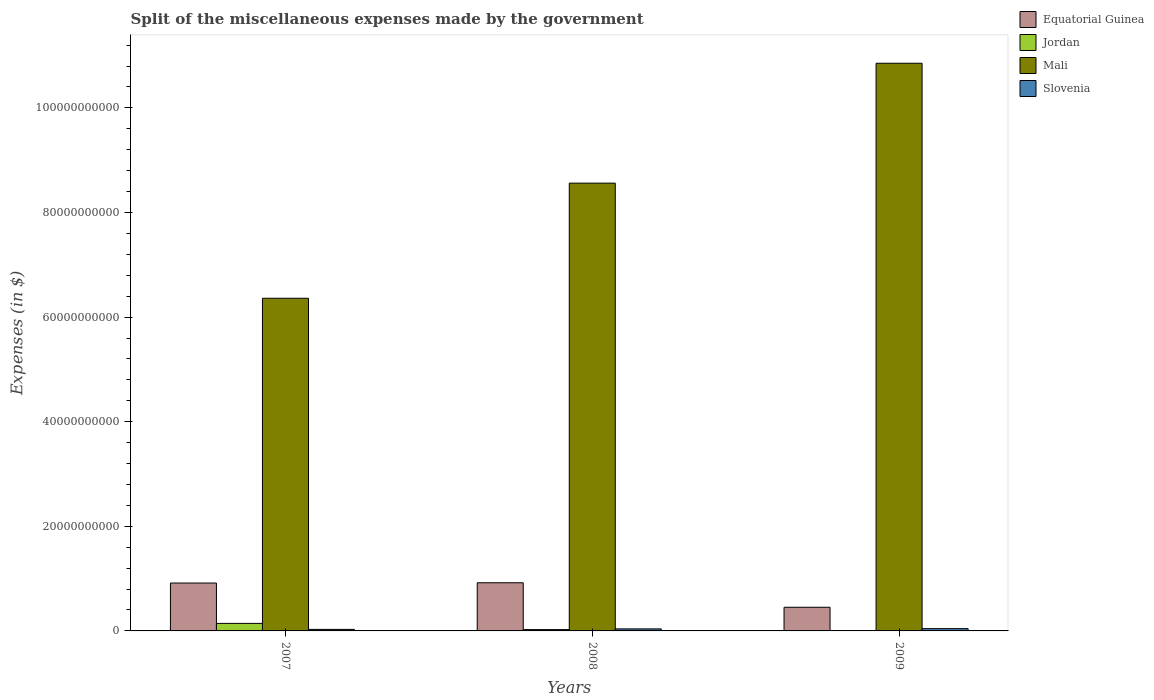How many groups of bars are there?
Offer a very short reply. 3. Are the number of bars per tick equal to the number of legend labels?
Provide a succinct answer. Yes. Are the number of bars on each tick of the X-axis equal?
Keep it short and to the point. Yes. How many bars are there on the 3rd tick from the right?
Your answer should be very brief. 4. In how many cases, is the number of bars for a given year not equal to the number of legend labels?
Make the answer very short. 0. What is the miscellaneous expenses made by the government in Jordan in 2007?
Your response must be concise. 1.44e+09. Across all years, what is the maximum miscellaneous expenses made by the government in Equatorial Guinea?
Offer a very short reply. 9.21e+09. Across all years, what is the minimum miscellaneous expenses made by the government in Equatorial Guinea?
Provide a short and direct response. 4.52e+09. In which year was the miscellaneous expenses made by the government in Slovenia maximum?
Give a very brief answer. 2009. What is the total miscellaneous expenses made by the government in Equatorial Guinea in the graph?
Keep it short and to the point. 2.29e+1. What is the difference between the miscellaneous expenses made by the government in Mali in 2007 and that in 2008?
Offer a very short reply. -2.20e+1. What is the difference between the miscellaneous expenses made by the government in Slovenia in 2007 and the miscellaneous expenses made by the government in Jordan in 2009?
Give a very brief answer. 2.18e+08. What is the average miscellaneous expenses made by the government in Jordan per year?
Your answer should be very brief. 5.90e+08. In the year 2009, what is the difference between the miscellaneous expenses made by the government in Jordan and miscellaneous expenses made by the government in Equatorial Guinea?
Your answer should be very brief. -4.44e+09. In how many years, is the miscellaneous expenses made by the government in Mali greater than 80000000000 $?
Keep it short and to the point. 2. What is the ratio of the miscellaneous expenses made by the government in Slovenia in 2008 to that in 2009?
Provide a short and direct response. 0.9. Is the difference between the miscellaneous expenses made by the government in Jordan in 2008 and 2009 greater than the difference between the miscellaneous expenses made by the government in Equatorial Guinea in 2008 and 2009?
Offer a terse response. No. What is the difference between the highest and the second highest miscellaneous expenses made by the government in Jordan?
Provide a succinct answer. 1.18e+09. What is the difference between the highest and the lowest miscellaneous expenses made by the government in Slovenia?
Offer a terse response. 1.38e+08. Is the sum of the miscellaneous expenses made by the government in Mali in 2008 and 2009 greater than the maximum miscellaneous expenses made by the government in Slovenia across all years?
Provide a succinct answer. Yes. What does the 4th bar from the left in 2009 represents?
Offer a terse response. Slovenia. What does the 2nd bar from the right in 2008 represents?
Provide a short and direct response. Mali. Is it the case that in every year, the sum of the miscellaneous expenses made by the government in Slovenia and miscellaneous expenses made by the government in Mali is greater than the miscellaneous expenses made by the government in Jordan?
Your answer should be compact. Yes. How many years are there in the graph?
Your response must be concise. 3. What is the difference between two consecutive major ticks on the Y-axis?
Keep it short and to the point. 2.00e+1. Does the graph contain grids?
Ensure brevity in your answer.  No. Where does the legend appear in the graph?
Your answer should be compact. Top right. How are the legend labels stacked?
Ensure brevity in your answer.  Vertical. What is the title of the graph?
Offer a terse response. Split of the miscellaneous expenses made by the government. Does "Sri Lanka" appear as one of the legend labels in the graph?
Offer a terse response. No. What is the label or title of the X-axis?
Offer a very short reply. Years. What is the label or title of the Y-axis?
Provide a short and direct response. Expenses (in $). What is the Expenses (in $) of Equatorial Guinea in 2007?
Make the answer very short. 9.16e+09. What is the Expenses (in $) in Jordan in 2007?
Offer a very short reply. 1.44e+09. What is the Expenses (in $) of Mali in 2007?
Provide a short and direct response. 6.36e+1. What is the Expenses (in $) of Slovenia in 2007?
Provide a short and direct response. 2.95e+08. What is the Expenses (in $) of Equatorial Guinea in 2008?
Give a very brief answer. 9.21e+09. What is the Expenses (in $) in Jordan in 2008?
Provide a succinct answer. 2.55e+08. What is the Expenses (in $) in Mali in 2008?
Give a very brief answer. 8.56e+1. What is the Expenses (in $) of Slovenia in 2008?
Keep it short and to the point. 3.89e+08. What is the Expenses (in $) in Equatorial Guinea in 2009?
Your response must be concise. 4.52e+09. What is the Expenses (in $) in Jordan in 2009?
Your response must be concise. 7.76e+07. What is the Expenses (in $) in Mali in 2009?
Offer a terse response. 1.09e+11. What is the Expenses (in $) of Slovenia in 2009?
Ensure brevity in your answer.  4.33e+08. Across all years, what is the maximum Expenses (in $) in Equatorial Guinea?
Give a very brief answer. 9.21e+09. Across all years, what is the maximum Expenses (in $) in Jordan?
Offer a very short reply. 1.44e+09. Across all years, what is the maximum Expenses (in $) of Mali?
Ensure brevity in your answer.  1.09e+11. Across all years, what is the maximum Expenses (in $) of Slovenia?
Give a very brief answer. 4.33e+08. Across all years, what is the minimum Expenses (in $) of Equatorial Guinea?
Your answer should be very brief. 4.52e+09. Across all years, what is the minimum Expenses (in $) in Jordan?
Your answer should be very brief. 7.76e+07. Across all years, what is the minimum Expenses (in $) in Mali?
Offer a terse response. 6.36e+1. Across all years, what is the minimum Expenses (in $) of Slovenia?
Give a very brief answer. 2.95e+08. What is the total Expenses (in $) in Equatorial Guinea in the graph?
Give a very brief answer. 2.29e+1. What is the total Expenses (in $) of Jordan in the graph?
Provide a succinct answer. 1.77e+09. What is the total Expenses (in $) in Mali in the graph?
Your response must be concise. 2.58e+11. What is the total Expenses (in $) in Slovenia in the graph?
Your answer should be compact. 1.12e+09. What is the difference between the Expenses (in $) in Equatorial Guinea in 2007 and that in 2008?
Your answer should be very brief. -5.30e+07. What is the difference between the Expenses (in $) in Jordan in 2007 and that in 2008?
Provide a short and direct response. 1.18e+09. What is the difference between the Expenses (in $) in Mali in 2007 and that in 2008?
Keep it short and to the point. -2.20e+1. What is the difference between the Expenses (in $) of Slovenia in 2007 and that in 2008?
Offer a terse response. -9.37e+07. What is the difference between the Expenses (in $) in Equatorial Guinea in 2007 and that in 2009?
Provide a succinct answer. 4.63e+09. What is the difference between the Expenses (in $) of Jordan in 2007 and that in 2009?
Your answer should be very brief. 1.36e+09. What is the difference between the Expenses (in $) of Mali in 2007 and that in 2009?
Ensure brevity in your answer.  -4.49e+1. What is the difference between the Expenses (in $) in Slovenia in 2007 and that in 2009?
Your answer should be very brief. -1.38e+08. What is the difference between the Expenses (in $) of Equatorial Guinea in 2008 and that in 2009?
Offer a terse response. 4.69e+09. What is the difference between the Expenses (in $) of Jordan in 2008 and that in 2009?
Provide a succinct answer. 1.78e+08. What is the difference between the Expenses (in $) in Mali in 2008 and that in 2009?
Keep it short and to the point. -2.29e+1. What is the difference between the Expenses (in $) of Slovenia in 2008 and that in 2009?
Offer a very short reply. -4.41e+07. What is the difference between the Expenses (in $) of Equatorial Guinea in 2007 and the Expenses (in $) of Jordan in 2008?
Your response must be concise. 8.90e+09. What is the difference between the Expenses (in $) in Equatorial Guinea in 2007 and the Expenses (in $) in Mali in 2008?
Give a very brief answer. -7.65e+1. What is the difference between the Expenses (in $) of Equatorial Guinea in 2007 and the Expenses (in $) of Slovenia in 2008?
Offer a terse response. 8.77e+09. What is the difference between the Expenses (in $) of Jordan in 2007 and the Expenses (in $) of Mali in 2008?
Your answer should be compact. -8.42e+1. What is the difference between the Expenses (in $) in Jordan in 2007 and the Expenses (in $) in Slovenia in 2008?
Offer a very short reply. 1.05e+09. What is the difference between the Expenses (in $) of Mali in 2007 and the Expenses (in $) of Slovenia in 2008?
Ensure brevity in your answer.  6.32e+1. What is the difference between the Expenses (in $) of Equatorial Guinea in 2007 and the Expenses (in $) of Jordan in 2009?
Make the answer very short. 9.08e+09. What is the difference between the Expenses (in $) in Equatorial Guinea in 2007 and the Expenses (in $) in Mali in 2009?
Keep it short and to the point. -9.94e+1. What is the difference between the Expenses (in $) in Equatorial Guinea in 2007 and the Expenses (in $) in Slovenia in 2009?
Ensure brevity in your answer.  8.72e+09. What is the difference between the Expenses (in $) of Jordan in 2007 and the Expenses (in $) of Mali in 2009?
Offer a very short reply. -1.07e+11. What is the difference between the Expenses (in $) of Jordan in 2007 and the Expenses (in $) of Slovenia in 2009?
Keep it short and to the point. 1.01e+09. What is the difference between the Expenses (in $) in Mali in 2007 and the Expenses (in $) in Slovenia in 2009?
Keep it short and to the point. 6.32e+1. What is the difference between the Expenses (in $) in Equatorial Guinea in 2008 and the Expenses (in $) in Jordan in 2009?
Give a very brief answer. 9.13e+09. What is the difference between the Expenses (in $) in Equatorial Guinea in 2008 and the Expenses (in $) in Mali in 2009?
Ensure brevity in your answer.  -9.93e+1. What is the difference between the Expenses (in $) in Equatorial Guinea in 2008 and the Expenses (in $) in Slovenia in 2009?
Ensure brevity in your answer.  8.78e+09. What is the difference between the Expenses (in $) of Jordan in 2008 and the Expenses (in $) of Mali in 2009?
Ensure brevity in your answer.  -1.08e+11. What is the difference between the Expenses (in $) of Jordan in 2008 and the Expenses (in $) of Slovenia in 2009?
Keep it short and to the point. -1.78e+08. What is the difference between the Expenses (in $) of Mali in 2008 and the Expenses (in $) of Slovenia in 2009?
Give a very brief answer. 8.52e+1. What is the average Expenses (in $) of Equatorial Guinea per year?
Make the answer very short. 7.63e+09. What is the average Expenses (in $) of Jordan per year?
Your response must be concise. 5.90e+08. What is the average Expenses (in $) in Mali per year?
Provide a short and direct response. 8.59e+1. What is the average Expenses (in $) in Slovenia per year?
Offer a very short reply. 3.73e+08. In the year 2007, what is the difference between the Expenses (in $) in Equatorial Guinea and Expenses (in $) in Jordan?
Ensure brevity in your answer.  7.72e+09. In the year 2007, what is the difference between the Expenses (in $) of Equatorial Guinea and Expenses (in $) of Mali?
Your answer should be compact. -5.44e+1. In the year 2007, what is the difference between the Expenses (in $) of Equatorial Guinea and Expenses (in $) of Slovenia?
Your response must be concise. 8.86e+09. In the year 2007, what is the difference between the Expenses (in $) of Jordan and Expenses (in $) of Mali?
Offer a very short reply. -6.22e+1. In the year 2007, what is the difference between the Expenses (in $) of Jordan and Expenses (in $) of Slovenia?
Keep it short and to the point. 1.14e+09. In the year 2007, what is the difference between the Expenses (in $) in Mali and Expenses (in $) in Slovenia?
Make the answer very short. 6.33e+1. In the year 2008, what is the difference between the Expenses (in $) of Equatorial Guinea and Expenses (in $) of Jordan?
Offer a very short reply. 8.95e+09. In the year 2008, what is the difference between the Expenses (in $) in Equatorial Guinea and Expenses (in $) in Mali?
Your response must be concise. -7.64e+1. In the year 2008, what is the difference between the Expenses (in $) in Equatorial Guinea and Expenses (in $) in Slovenia?
Make the answer very short. 8.82e+09. In the year 2008, what is the difference between the Expenses (in $) of Jordan and Expenses (in $) of Mali?
Provide a short and direct response. -8.54e+1. In the year 2008, what is the difference between the Expenses (in $) of Jordan and Expenses (in $) of Slovenia?
Give a very brief answer. -1.34e+08. In the year 2008, what is the difference between the Expenses (in $) in Mali and Expenses (in $) in Slovenia?
Your answer should be very brief. 8.52e+1. In the year 2009, what is the difference between the Expenses (in $) of Equatorial Guinea and Expenses (in $) of Jordan?
Provide a short and direct response. 4.44e+09. In the year 2009, what is the difference between the Expenses (in $) in Equatorial Guinea and Expenses (in $) in Mali?
Your response must be concise. -1.04e+11. In the year 2009, what is the difference between the Expenses (in $) in Equatorial Guinea and Expenses (in $) in Slovenia?
Ensure brevity in your answer.  4.09e+09. In the year 2009, what is the difference between the Expenses (in $) in Jordan and Expenses (in $) in Mali?
Make the answer very short. -1.08e+11. In the year 2009, what is the difference between the Expenses (in $) of Jordan and Expenses (in $) of Slovenia?
Your answer should be compact. -3.56e+08. In the year 2009, what is the difference between the Expenses (in $) of Mali and Expenses (in $) of Slovenia?
Make the answer very short. 1.08e+11. What is the ratio of the Expenses (in $) of Equatorial Guinea in 2007 to that in 2008?
Your answer should be very brief. 0.99. What is the ratio of the Expenses (in $) of Jordan in 2007 to that in 2008?
Ensure brevity in your answer.  5.63. What is the ratio of the Expenses (in $) in Mali in 2007 to that in 2008?
Give a very brief answer. 0.74. What is the ratio of the Expenses (in $) in Slovenia in 2007 to that in 2008?
Keep it short and to the point. 0.76. What is the ratio of the Expenses (in $) of Equatorial Guinea in 2007 to that in 2009?
Your answer should be very brief. 2.02. What is the ratio of the Expenses (in $) in Jordan in 2007 to that in 2009?
Provide a succinct answer. 18.54. What is the ratio of the Expenses (in $) of Mali in 2007 to that in 2009?
Your answer should be compact. 0.59. What is the ratio of the Expenses (in $) in Slovenia in 2007 to that in 2009?
Give a very brief answer. 0.68. What is the ratio of the Expenses (in $) of Equatorial Guinea in 2008 to that in 2009?
Make the answer very short. 2.04. What is the ratio of the Expenses (in $) in Jordan in 2008 to that in 2009?
Make the answer very short. 3.29. What is the ratio of the Expenses (in $) in Mali in 2008 to that in 2009?
Your response must be concise. 0.79. What is the ratio of the Expenses (in $) of Slovenia in 2008 to that in 2009?
Keep it short and to the point. 0.9. What is the difference between the highest and the second highest Expenses (in $) of Equatorial Guinea?
Offer a terse response. 5.30e+07. What is the difference between the highest and the second highest Expenses (in $) of Jordan?
Your answer should be very brief. 1.18e+09. What is the difference between the highest and the second highest Expenses (in $) of Mali?
Offer a very short reply. 2.29e+1. What is the difference between the highest and the second highest Expenses (in $) of Slovenia?
Provide a short and direct response. 4.41e+07. What is the difference between the highest and the lowest Expenses (in $) in Equatorial Guinea?
Make the answer very short. 4.69e+09. What is the difference between the highest and the lowest Expenses (in $) of Jordan?
Provide a succinct answer. 1.36e+09. What is the difference between the highest and the lowest Expenses (in $) of Mali?
Your answer should be very brief. 4.49e+1. What is the difference between the highest and the lowest Expenses (in $) of Slovenia?
Your answer should be very brief. 1.38e+08. 